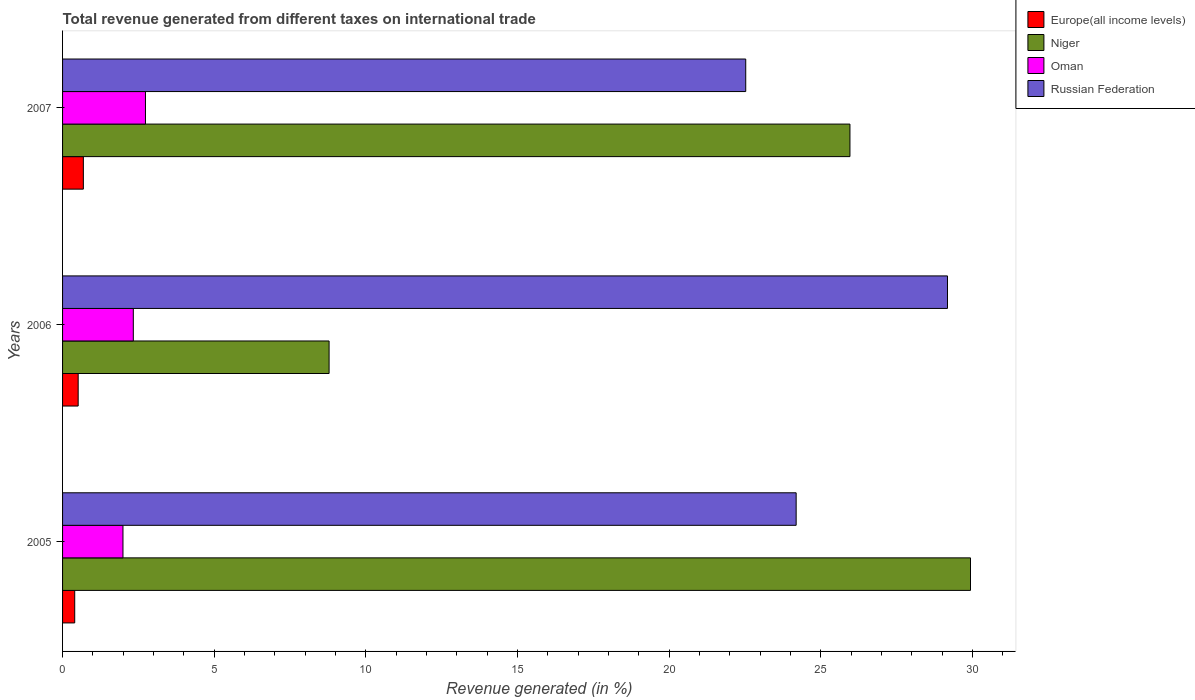Are the number of bars per tick equal to the number of legend labels?
Your answer should be very brief. Yes. Are the number of bars on each tick of the Y-axis equal?
Your answer should be compact. Yes. In how many cases, is the number of bars for a given year not equal to the number of legend labels?
Provide a short and direct response. 0. What is the total revenue generated in Europe(all income levels) in 2005?
Keep it short and to the point. 0.4. Across all years, what is the maximum total revenue generated in Europe(all income levels)?
Provide a succinct answer. 0.69. Across all years, what is the minimum total revenue generated in Russian Federation?
Keep it short and to the point. 22.52. What is the total total revenue generated in Oman in the graph?
Provide a short and direct response. 7.06. What is the difference between the total revenue generated in Russian Federation in 2005 and that in 2007?
Provide a succinct answer. 1.66. What is the difference between the total revenue generated in Russian Federation in 2006 and the total revenue generated in Europe(all income levels) in 2005?
Provide a short and direct response. 28.78. What is the average total revenue generated in Niger per year?
Provide a succinct answer. 21.56. In the year 2005, what is the difference between the total revenue generated in Russian Federation and total revenue generated in Niger?
Give a very brief answer. -5.75. In how many years, is the total revenue generated in Oman greater than 24 %?
Offer a terse response. 0. What is the ratio of the total revenue generated in Niger in 2006 to that in 2007?
Ensure brevity in your answer.  0.34. Is the difference between the total revenue generated in Russian Federation in 2005 and 2007 greater than the difference between the total revenue generated in Niger in 2005 and 2007?
Your answer should be compact. No. What is the difference between the highest and the second highest total revenue generated in Oman?
Ensure brevity in your answer.  0.4. What is the difference between the highest and the lowest total revenue generated in Oman?
Offer a very short reply. 0.74. In how many years, is the total revenue generated in Russian Federation greater than the average total revenue generated in Russian Federation taken over all years?
Offer a very short reply. 1. Is the sum of the total revenue generated in Russian Federation in 2005 and 2006 greater than the maximum total revenue generated in Europe(all income levels) across all years?
Offer a very short reply. Yes. What does the 4th bar from the top in 2007 represents?
Your answer should be compact. Europe(all income levels). What does the 4th bar from the bottom in 2007 represents?
Keep it short and to the point. Russian Federation. Is it the case that in every year, the sum of the total revenue generated in Russian Federation and total revenue generated in Europe(all income levels) is greater than the total revenue generated in Oman?
Offer a terse response. Yes. How many bars are there?
Make the answer very short. 12. Does the graph contain any zero values?
Offer a terse response. No. Where does the legend appear in the graph?
Keep it short and to the point. Top right. How many legend labels are there?
Provide a short and direct response. 4. How are the legend labels stacked?
Offer a very short reply. Vertical. What is the title of the graph?
Provide a short and direct response. Total revenue generated from different taxes on international trade. Does "Aruba" appear as one of the legend labels in the graph?
Make the answer very short. No. What is the label or title of the X-axis?
Your response must be concise. Revenue generated (in %). What is the label or title of the Y-axis?
Provide a succinct answer. Years. What is the Revenue generated (in %) in Europe(all income levels) in 2005?
Your answer should be compact. 0.4. What is the Revenue generated (in %) of Niger in 2005?
Your answer should be very brief. 29.93. What is the Revenue generated (in %) of Oman in 2005?
Keep it short and to the point. 1.99. What is the Revenue generated (in %) in Russian Federation in 2005?
Provide a short and direct response. 24.19. What is the Revenue generated (in %) of Europe(all income levels) in 2006?
Provide a succinct answer. 0.51. What is the Revenue generated (in %) in Niger in 2006?
Your answer should be compact. 8.79. What is the Revenue generated (in %) in Oman in 2006?
Provide a succinct answer. 2.33. What is the Revenue generated (in %) of Russian Federation in 2006?
Make the answer very short. 29.18. What is the Revenue generated (in %) in Europe(all income levels) in 2007?
Provide a succinct answer. 0.69. What is the Revenue generated (in %) of Niger in 2007?
Ensure brevity in your answer.  25.96. What is the Revenue generated (in %) in Oman in 2007?
Your answer should be compact. 2.73. What is the Revenue generated (in %) of Russian Federation in 2007?
Provide a succinct answer. 22.52. Across all years, what is the maximum Revenue generated (in %) of Europe(all income levels)?
Offer a very short reply. 0.69. Across all years, what is the maximum Revenue generated (in %) of Niger?
Ensure brevity in your answer.  29.93. Across all years, what is the maximum Revenue generated (in %) in Oman?
Ensure brevity in your answer.  2.73. Across all years, what is the maximum Revenue generated (in %) of Russian Federation?
Make the answer very short. 29.18. Across all years, what is the minimum Revenue generated (in %) in Europe(all income levels)?
Your answer should be compact. 0.4. Across all years, what is the minimum Revenue generated (in %) in Niger?
Offer a terse response. 8.79. Across all years, what is the minimum Revenue generated (in %) in Oman?
Offer a very short reply. 1.99. Across all years, what is the minimum Revenue generated (in %) in Russian Federation?
Make the answer very short. 22.52. What is the total Revenue generated (in %) in Europe(all income levels) in the graph?
Offer a terse response. 1.6. What is the total Revenue generated (in %) of Niger in the graph?
Provide a succinct answer. 64.68. What is the total Revenue generated (in %) of Oman in the graph?
Offer a terse response. 7.06. What is the total Revenue generated (in %) in Russian Federation in the graph?
Your response must be concise. 75.89. What is the difference between the Revenue generated (in %) in Europe(all income levels) in 2005 and that in 2006?
Offer a terse response. -0.11. What is the difference between the Revenue generated (in %) in Niger in 2005 and that in 2006?
Provide a short and direct response. 21.15. What is the difference between the Revenue generated (in %) of Oman in 2005 and that in 2006?
Your answer should be compact. -0.34. What is the difference between the Revenue generated (in %) in Russian Federation in 2005 and that in 2006?
Offer a terse response. -4.99. What is the difference between the Revenue generated (in %) of Europe(all income levels) in 2005 and that in 2007?
Provide a short and direct response. -0.28. What is the difference between the Revenue generated (in %) in Niger in 2005 and that in 2007?
Provide a succinct answer. 3.97. What is the difference between the Revenue generated (in %) of Oman in 2005 and that in 2007?
Ensure brevity in your answer.  -0.74. What is the difference between the Revenue generated (in %) in Russian Federation in 2005 and that in 2007?
Keep it short and to the point. 1.66. What is the difference between the Revenue generated (in %) in Europe(all income levels) in 2006 and that in 2007?
Your response must be concise. -0.17. What is the difference between the Revenue generated (in %) of Niger in 2006 and that in 2007?
Your response must be concise. -17.17. What is the difference between the Revenue generated (in %) in Oman in 2006 and that in 2007?
Provide a succinct answer. -0.4. What is the difference between the Revenue generated (in %) of Russian Federation in 2006 and that in 2007?
Offer a terse response. 6.65. What is the difference between the Revenue generated (in %) of Europe(all income levels) in 2005 and the Revenue generated (in %) of Niger in 2006?
Your answer should be compact. -8.39. What is the difference between the Revenue generated (in %) in Europe(all income levels) in 2005 and the Revenue generated (in %) in Oman in 2006?
Your response must be concise. -1.93. What is the difference between the Revenue generated (in %) in Europe(all income levels) in 2005 and the Revenue generated (in %) in Russian Federation in 2006?
Ensure brevity in your answer.  -28.78. What is the difference between the Revenue generated (in %) in Niger in 2005 and the Revenue generated (in %) in Oman in 2006?
Your answer should be compact. 27.6. What is the difference between the Revenue generated (in %) in Niger in 2005 and the Revenue generated (in %) in Russian Federation in 2006?
Provide a short and direct response. 0.76. What is the difference between the Revenue generated (in %) of Oman in 2005 and the Revenue generated (in %) of Russian Federation in 2006?
Your response must be concise. -27.18. What is the difference between the Revenue generated (in %) in Europe(all income levels) in 2005 and the Revenue generated (in %) in Niger in 2007?
Provide a short and direct response. -25.56. What is the difference between the Revenue generated (in %) in Europe(all income levels) in 2005 and the Revenue generated (in %) in Oman in 2007?
Provide a short and direct response. -2.33. What is the difference between the Revenue generated (in %) in Europe(all income levels) in 2005 and the Revenue generated (in %) in Russian Federation in 2007?
Ensure brevity in your answer.  -22.12. What is the difference between the Revenue generated (in %) in Niger in 2005 and the Revenue generated (in %) in Oman in 2007?
Offer a terse response. 27.2. What is the difference between the Revenue generated (in %) of Niger in 2005 and the Revenue generated (in %) of Russian Federation in 2007?
Offer a terse response. 7.41. What is the difference between the Revenue generated (in %) in Oman in 2005 and the Revenue generated (in %) in Russian Federation in 2007?
Provide a short and direct response. -20.53. What is the difference between the Revenue generated (in %) of Europe(all income levels) in 2006 and the Revenue generated (in %) of Niger in 2007?
Offer a very short reply. -25.45. What is the difference between the Revenue generated (in %) in Europe(all income levels) in 2006 and the Revenue generated (in %) in Oman in 2007?
Give a very brief answer. -2.22. What is the difference between the Revenue generated (in %) of Europe(all income levels) in 2006 and the Revenue generated (in %) of Russian Federation in 2007?
Provide a short and direct response. -22.01. What is the difference between the Revenue generated (in %) of Niger in 2006 and the Revenue generated (in %) of Oman in 2007?
Your response must be concise. 6.05. What is the difference between the Revenue generated (in %) in Niger in 2006 and the Revenue generated (in %) in Russian Federation in 2007?
Provide a short and direct response. -13.74. What is the difference between the Revenue generated (in %) of Oman in 2006 and the Revenue generated (in %) of Russian Federation in 2007?
Your answer should be compact. -20.19. What is the average Revenue generated (in %) in Europe(all income levels) per year?
Provide a short and direct response. 0.53. What is the average Revenue generated (in %) in Niger per year?
Offer a very short reply. 21.56. What is the average Revenue generated (in %) in Oman per year?
Ensure brevity in your answer.  2.35. What is the average Revenue generated (in %) in Russian Federation per year?
Give a very brief answer. 25.3. In the year 2005, what is the difference between the Revenue generated (in %) of Europe(all income levels) and Revenue generated (in %) of Niger?
Provide a short and direct response. -29.53. In the year 2005, what is the difference between the Revenue generated (in %) of Europe(all income levels) and Revenue generated (in %) of Oman?
Ensure brevity in your answer.  -1.59. In the year 2005, what is the difference between the Revenue generated (in %) in Europe(all income levels) and Revenue generated (in %) in Russian Federation?
Ensure brevity in your answer.  -23.79. In the year 2005, what is the difference between the Revenue generated (in %) in Niger and Revenue generated (in %) in Oman?
Provide a short and direct response. 27.94. In the year 2005, what is the difference between the Revenue generated (in %) in Niger and Revenue generated (in %) in Russian Federation?
Give a very brief answer. 5.75. In the year 2005, what is the difference between the Revenue generated (in %) of Oman and Revenue generated (in %) of Russian Federation?
Make the answer very short. -22.19. In the year 2006, what is the difference between the Revenue generated (in %) in Europe(all income levels) and Revenue generated (in %) in Niger?
Offer a terse response. -8.27. In the year 2006, what is the difference between the Revenue generated (in %) in Europe(all income levels) and Revenue generated (in %) in Oman?
Give a very brief answer. -1.82. In the year 2006, what is the difference between the Revenue generated (in %) in Europe(all income levels) and Revenue generated (in %) in Russian Federation?
Provide a succinct answer. -28.66. In the year 2006, what is the difference between the Revenue generated (in %) in Niger and Revenue generated (in %) in Oman?
Provide a succinct answer. 6.45. In the year 2006, what is the difference between the Revenue generated (in %) in Niger and Revenue generated (in %) in Russian Federation?
Provide a short and direct response. -20.39. In the year 2006, what is the difference between the Revenue generated (in %) in Oman and Revenue generated (in %) in Russian Federation?
Your answer should be very brief. -26.84. In the year 2007, what is the difference between the Revenue generated (in %) of Europe(all income levels) and Revenue generated (in %) of Niger?
Keep it short and to the point. -25.27. In the year 2007, what is the difference between the Revenue generated (in %) in Europe(all income levels) and Revenue generated (in %) in Oman?
Your answer should be compact. -2.05. In the year 2007, what is the difference between the Revenue generated (in %) in Europe(all income levels) and Revenue generated (in %) in Russian Federation?
Give a very brief answer. -21.84. In the year 2007, what is the difference between the Revenue generated (in %) of Niger and Revenue generated (in %) of Oman?
Keep it short and to the point. 23.23. In the year 2007, what is the difference between the Revenue generated (in %) in Niger and Revenue generated (in %) in Russian Federation?
Give a very brief answer. 3.44. In the year 2007, what is the difference between the Revenue generated (in %) in Oman and Revenue generated (in %) in Russian Federation?
Give a very brief answer. -19.79. What is the ratio of the Revenue generated (in %) in Europe(all income levels) in 2005 to that in 2006?
Give a very brief answer. 0.78. What is the ratio of the Revenue generated (in %) of Niger in 2005 to that in 2006?
Provide a short and direct response. 3.41. What is the ratio of the Revenue generated (in %) in Oman in 2005 to that in 2006?
Ensure brevity in your answer.  0.85. What is the ratio of the Revenue generated (in %) of Russian Federation in 2005 to that in 2006?
Provide a short and direct response. 0.83. What is the ratio of the Revenue generated (in %) of Europe(all income levels) in 2005 to that in 2007?
Provide a short and direct response. 0.58. What is the ratio of the Revenue generated (in %) of Niger in 2005 to that in 2007?
Offer a very short reply. 1.15. What is the ratio of the Revenue generated (in %) in Oman in 2005 to that in 2007?
Offer a terse response. 0.73. What is the ratio of the Revenue generated (in %) in Russian Federation in 2005 to that in 2007?
Your answer should be compact. 1.07. What is the ratio of the Revenue generated (in %) in Europe(all income levels) in 2006 to that in 2007?
Your response must be concise. 0.75. What is the ratio of the Revenue generated (in %) in Niger in 2006 to that in 2007?
Keep it short and to the point. 0.34. What is the ratio of the Revenue generated (in %) in Oman in 2006 to that in 2007?
Provide a short and direct response. 0.85. What is the ratio of the Revenue generated (in %) in Russian Federation in 2006 to that in 2007?
Offer a terse response. 1.3. What is the difference between the highest and the second highest Revenue generated (in %) in Europe(all income levels)?
Provide a short and direct response. 0.17. What is the difference between the highest and the second highest Revenue generated (in %) in Niger?
Your answer should be very brief. 3.97. What is the difference between the highest and the second highest Revenue generated (in %) in Oman?
Offer a terse response. 0.4. What is the difference between the highest and the second highest Revenue generated (in %) of Russian Federation?
Provide a succinct answer. 4.99. What is the difference between the highest and the lowest Revenue generated (in %) of Europe(all income levels)?
Provide a short and direct response. 0.28. What is the difference between the highest and the lowest Revenue generated (in %) in Niger?
Give a very brief answer. 21.15. What is the difference between the highest and the lowest Revenue generated (in %) of Oman?
Provide a succinct answer. 0.74. What is the difference between the highest and the lowest Revenue generated (in %) of Russian Federation?
Give a very brief answer. 6.65. 